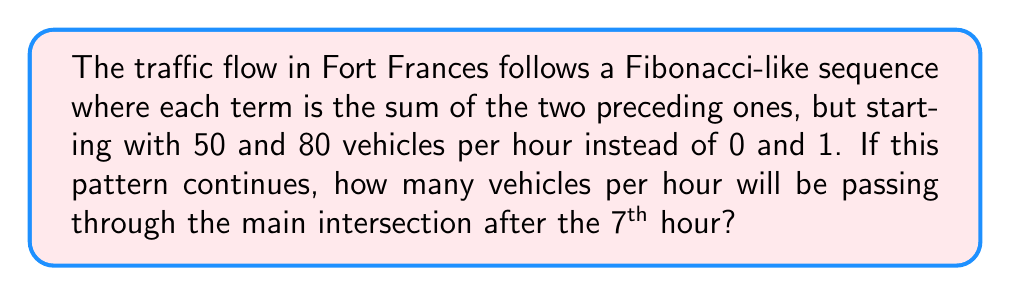Provide a solution to this math problem. Let's approach this step-by-step:

1) The sequence starts with 50 and 80 vehicles per hour.

2) We need to calculate the next 5 terms in the sequence to reach the 7th hour.

3) Let's calculate each term:
   
   1st hour: 50
   2nd hour: 80
   3rd hour: $50 + 80 = 130$
   4th hour: $80 + 130 = 210$
   5th hour: $130 + 210 = 340$
   6th hour: $210 + 340 = 550$
   7th hour: $340 + 550 = 890$

4) We can represent this sequence mathematically as:

   $$a_n = a_{n-1} + a_{n-2}$$

   where $a_1 = 50$, $a_2 = 80$, and $n \geq 3$

5) The complete sequence for the 7 hours is:

   $$50, 80, 130, 210, 340, 550, 890$$

Therefore, after the 7th hour, 890 vehicles per hour will be passing through the main intersection.
Answer: 890 vehicles per hour 